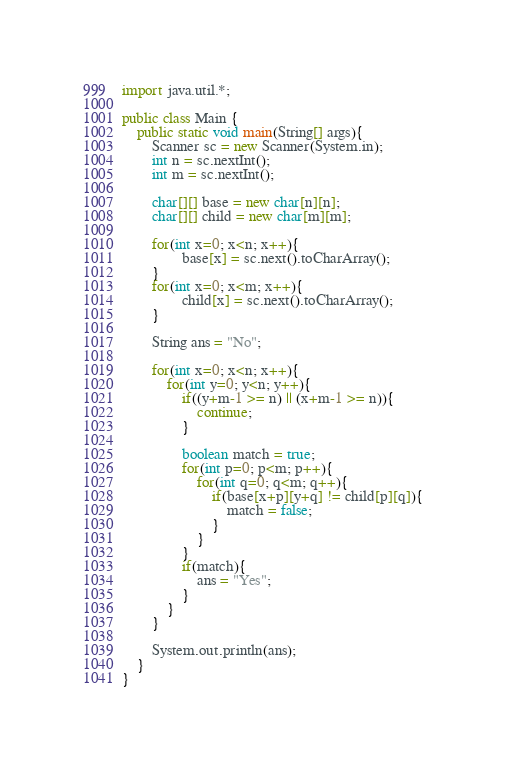<code> <loc_0><loc_0><loc_500><loc_500><_Java_>import java.util.*;

public class Main {
	public static void main(String[] args){
		Scanner sc = new Scanner(System.in);
        int n = sc.nextInt();
        int m = sc.nextInt();
        
        char[][] base = new char[n][n];
        char[][] child = new char[m][m];
     
        for(int x=0; x<n; x++){
                base[x] = sc.next().toCharArray();
        }
        for(int x=0; x<m; x++){
                child[x] = sc.next().toCharArray();
        }
        
        String ans = "No";
        
        for(int x=0; x<n; x++){
            for(int y=0; y<n; y++){
                if((y+m-1 >= n) || (x+m-1 >= n)){
                    continue;
                }
                
                boolean match = true;
                for(int p=0; p<m; p++){
                    for(int q=0; q<m; q++){
                        if(base[x+p][y+q] != child[p][q]){
                            match = false;
                        }
                    }
                }
                if(match){
                    ans = "Yes";
                }
            }
        }
       
        System.out.println(ans);
	}
}</code> 